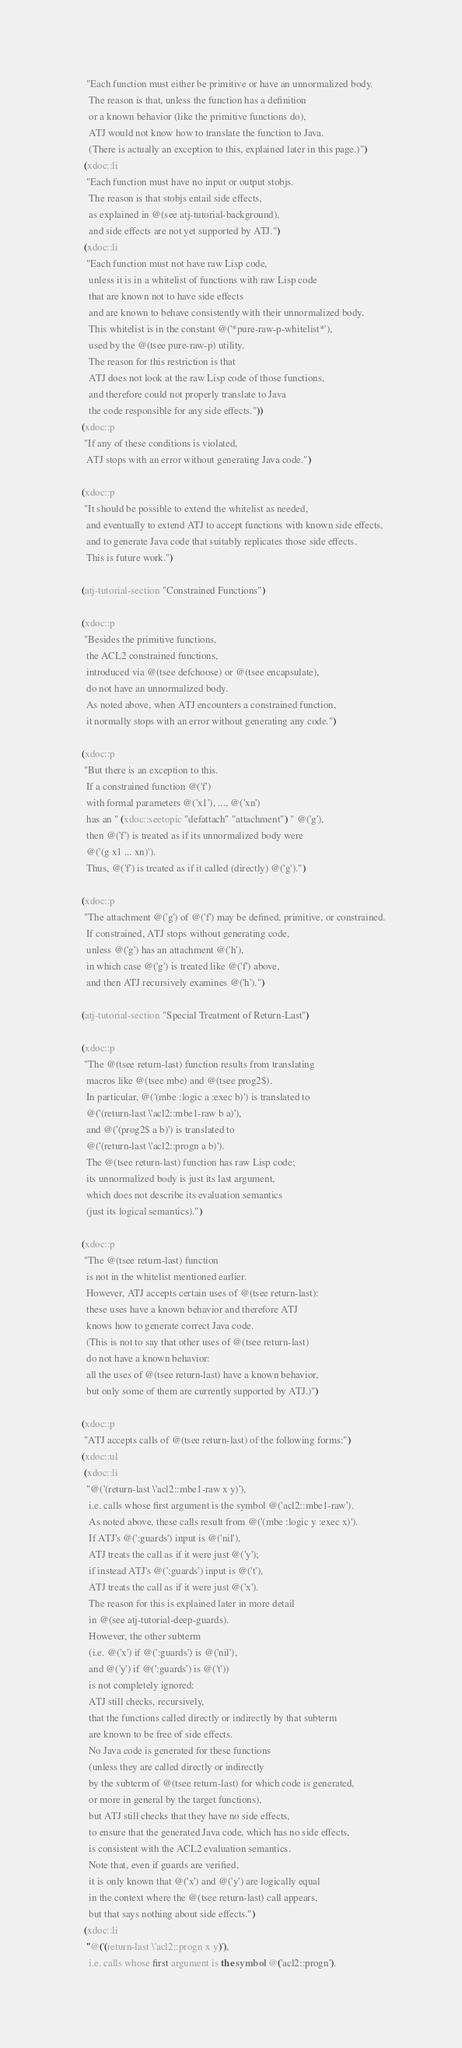<code> <loc_0><loc_0><loc_500><loc_500><_Lisp_>    "Each function must either be primitive or have an unnormalized body.
     The reason is that, unless the function has a definition
     or a known behavior (like the primitive functions do),
     ATJ would not know how to translate the function to Java.
     (There is actually an exception to this, explained later in this page.)")
   (xdoc::li
    "Each function must have no input or output stobjs.
     The reason is that stobjs entail side effects,
     as explained in @(see atj-tutorial-background),
     and side effects are not yet supported by ATJ.")
   (xdoc::li
    "Each function must not have raw Lisp code,
     unless it is in a whitelist of functions with raw Lisp code
     that are known not to have side effects
     and are known to behave consistently with their unnormalized body.
     This whitelist is in the constant @('*pure-raw-p-whitelist*'),
     used by the @(tsee pure-raw-p) utility.
     The reason for this restriction is that
     ATJ does not look at the raw Lisp code of those functions,
     and therefore could not properly translate to Java
     the code responsible for any side effects."))
  (xdoc::p
   "If any of these conditions is violated,
    ATJ stops with an error without generating Java code.")

  (xdoc::p
   "It should be possible to extend the whitelist as needed,
    and eventually to extend ATJ to accept functions with known side effects,
    and to generate Java code that suitably replicates those side effects.
    This is future work.")

  (atj-tutorial-section "Constrained Functions")

  (xdoc::p
   "Besides the primitive functions,
    the ACL2 constrained functions,
    introduced via @(tsee defchoose) or @(tsee encapsulate),
    do not have an unnormalized body.
    As noted above, when ATJ encounters a constrained function,
    it normally stops with an error without generating any code.")

  (xdoc::p
   "But there is an exception to this.
    If a constrained function @('f')
    with formal parameters @('x1'), ..., @('xn')
    has an " (xdoc::seetopic "defattach" "attachment") " @('g'),
    then @('f') is treated as if its unnormalized body were
    @('(g x1 ... xn)').
    Thus, @('f') is treated as if it called (directly) @('g').")

  (xdoc::p
   "The attachment @('g') of @('f') may be defined, primitive, or constrained.
    If constrained, ATJ stops without generating code,
    unless @('g') has an attachment @('h'),
    in which case @('g') is treated like @('f') above,
    and then ATJ recursively examines @('h').")

  (atj-tutorial-section "Special Treatment of Return-Last")

  (xdoc::p
   "The @(tsee return-last) function results from translating
    macros like @(tsee mbe) and @(tsee prog2$).
    In particular, @('(mbe :logic a :exec b)') is translated to
    @('(return-last \'acl2::mbe1-raw b a)'),
    and @('(prog2$ a b)') is translated to
    @('(return-last \'acl2::progn a b)').
    The @(tsee return-last) function has raw Lisp code;
    its unnormalized body is just its last argument,
    which does not describe its evaluation semantics
    (just its logical semantics).")

  (xdoc::p
   "The @(tsee return-last) function
    is not in the whitelist mentioned earlier.
    However, ATJ accepts certain uses of @(tsee return-last):
    these uses have a known behavior and therefore ATJ
    knows how to generate correct Java code.
    (This is not to say that other uses of @(tsee return-last)
    do not have a known behavior:
    all the uses of @(tsee return-last) have a known behavior,
    but only some of them are currently supported by ATJ.)")

  (xdoc::p
   "ATJ accepts calls of @(tsee return-last) of the following forms:")
  (xdoc::ul
   (xdoc::li
    "@('(return-last \'acl2::mbe1-raw x y)'),
     i.e. calls whose first argument is the symbol @('acl2::mbe1-raw').
     As noted above, these calls result from @('(mbe :logic y :exec x)').
     If ATJ's @(':guards') input is @('nil'),
     ATJ treats the call as if it were just @('y');
     if instead ATJ's @(':guards') input is @('t'),
     ATJ treats the call as if it were just @('x').
     The reason for this is explained later in more detail
     in @(see atj-tutorial-deep-guards).
     However, the other subterm
     (i.e. @('x') if @(':guards') is @('nil'),
     and @('y') if @(':guards') is @('t'))
     is not completely ignored:
     ATJ still checks, recursively,
     that the functions called directly or indirectly by that subterm
     are known to be free of side effects.
     No Java code is generated for these functions
     (unless they are called directly or indirectly
     by the subterm of @(tsee return-last) for which code is generated,
     or more in general by the target functions),
     but ATJ still checks that they have no side effects,
     to ensure that the generated Java code, which has no side effects,
     is consistent with the ACL2 evaluation semantics.
     Note that, even if guards are verified,
     it is only known that @('x') and @('y') are logically equal
     in the context where the @(tsee return-last) call appears,
     but that says nothing about side effects.")
   (xdoc::li
    "@('(return-last \'acl2::progn x y)'),
     i.e. calls whose first argument is the symbol @('acl2::progn').</code> 